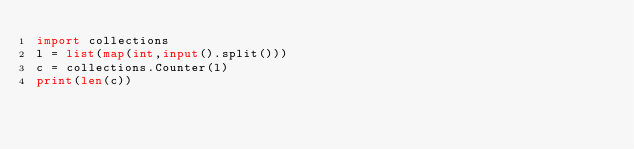Convert code to text. <code><loc_0><loc_0><loc_500><loc_500><_Python_>import collections
l = list(map(int,input().split()))
c = collections.Counter(l)
print(len(c))</code> 